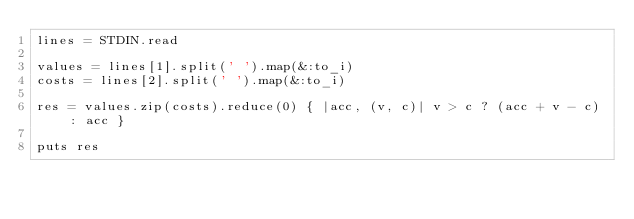<code> <loc_0><loc_0><loc_500><loc_500><_Ruby_>lines = STDIN.read

values = lines[1].split(' ').map(&:to_i)
costs = lines[2].split(' ').map(&:to_i)

res = values.zip(costs).reduce(0) { |acc, (v, c)| v > c ? (acc + v - c) : acc }

puts res
</code> 